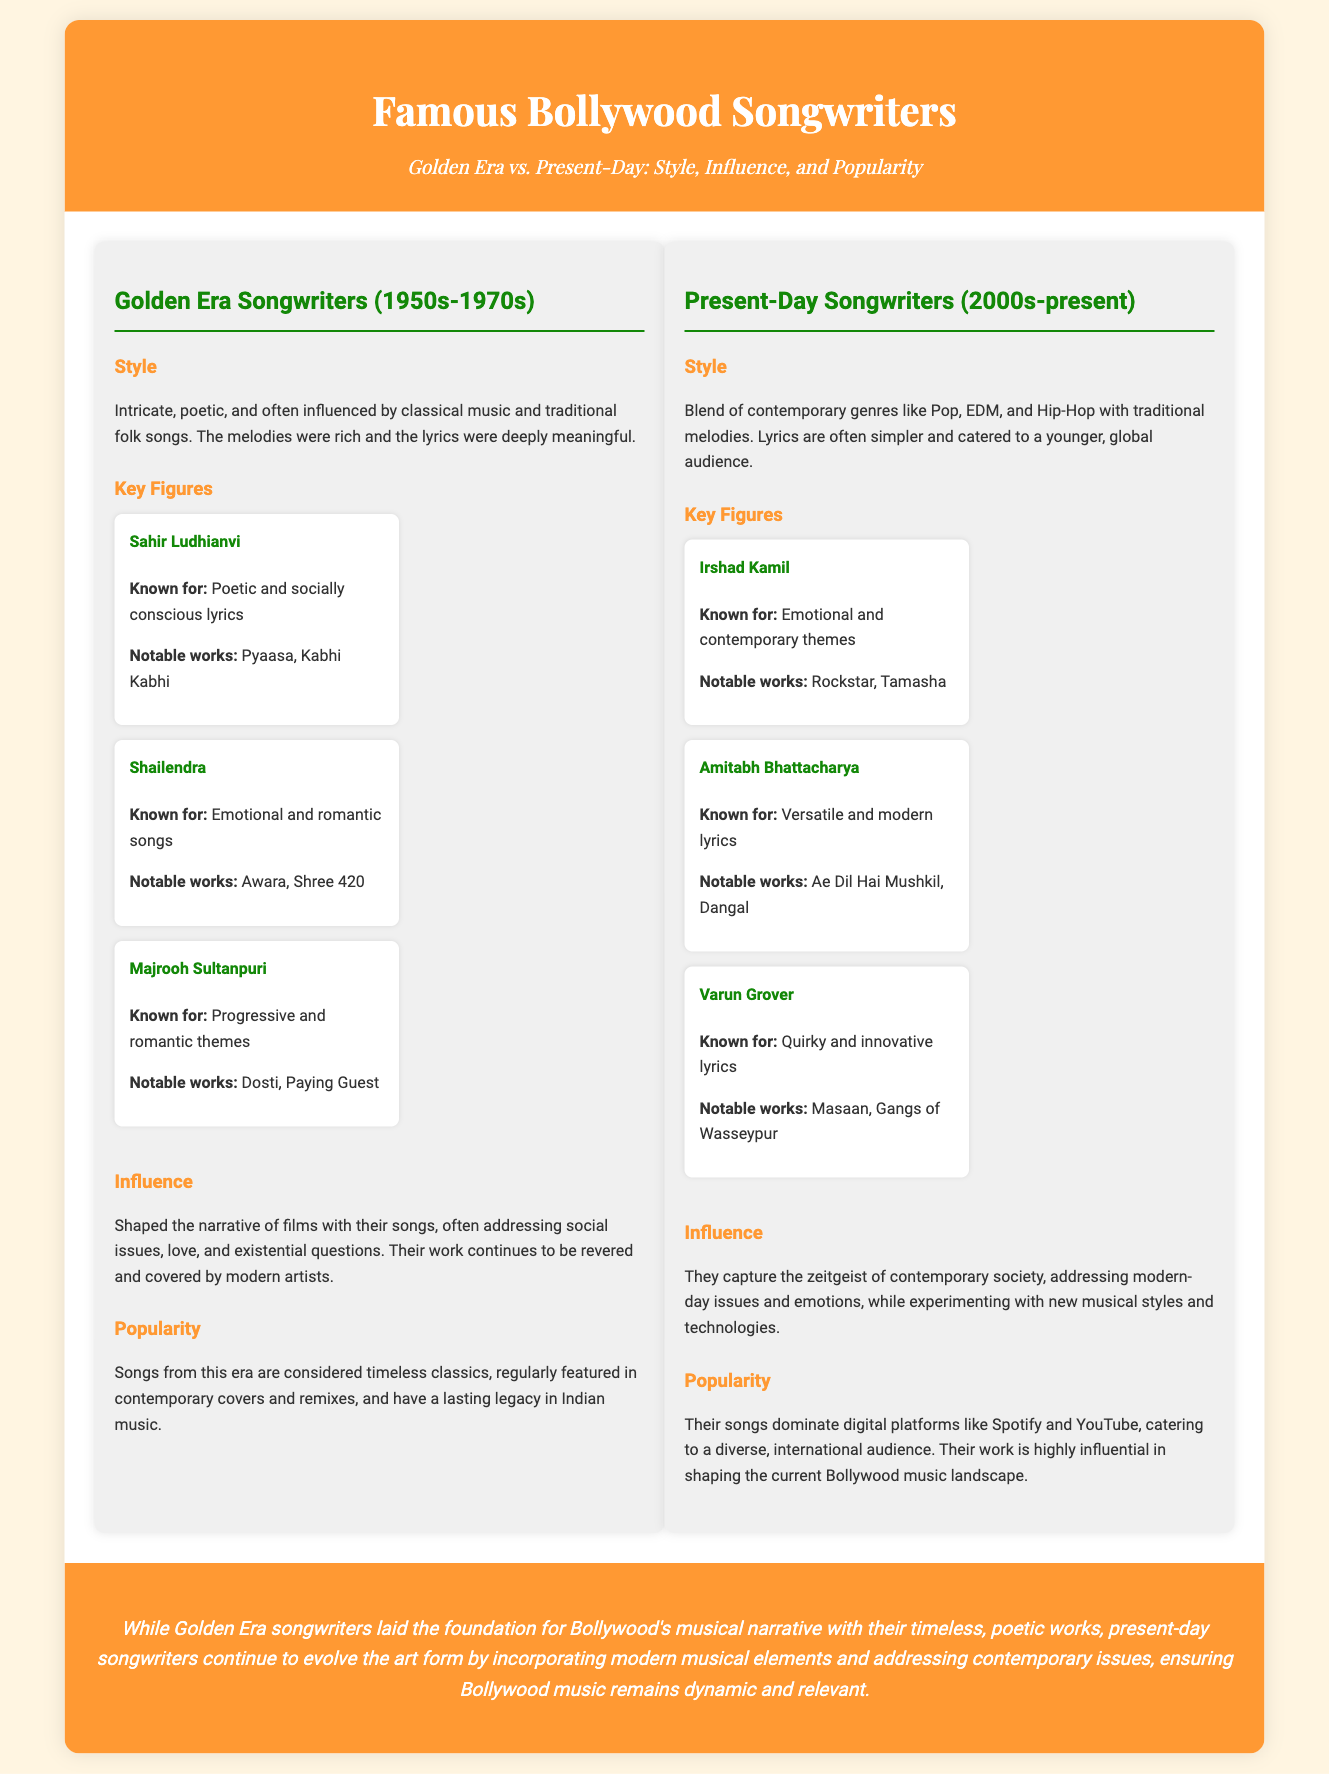What is the time period of the Golden Era songwriters? The document states that Golden Era songwriters were active from the 1950s to the 1970s.
Answer: 1950s-1970s Who is known for emotional and contemporary themes among present-day songwriters? The document mentions Irshad Kamil as the songwriter known for emotional and contemporary themes.
Answer: Irshad Kamil What style characterized Golden Era songwriters? The document describes the style of Golden Era songwriters as intricate, poetic, and influenced by classical music and traditional folk songs.
Answer: Intricate, poetic Which present-day songwriter is associated with innovative lyrics? The document identifies Varun Grover as the songwriter known for quirky and innovative lyrics.
Answer: Varun Grover What is the impact of Golden Era songwriters on modern artists? The document notes that their work continues to be revered and covered by modern artists.
Answer: Revered and covered How do present-day songwriters capture contemporary society? The document states that they capture the zeitgeist of contemporary society, addressing modern-day issues and emotions.
Answer: Zeitgeist of contemporary society What is the main theme of the comparison in the conclusion? The conclusion emphasizes the evolution of Bollywood music from the Golden Era to present-day by incorporating modern elements.
Answer: Evolution of Bollywood music Who are two notable songwriters from the Golden Era mentioned? The document lists Sahir Ludhianvi and Shailendra as notable songwriters from the Golden Era.
Answer: Sahir Ludhianvi, Shailendra 